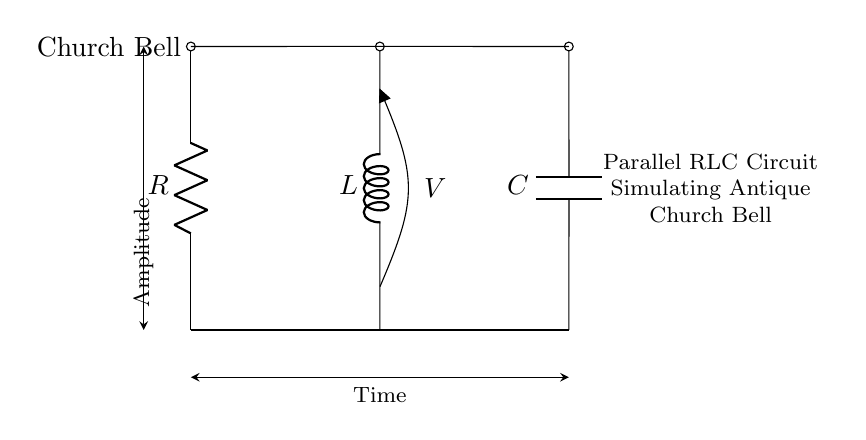What is the type of circuit represented here? This is a parallel RLC circuit, indicated by the arrangement of the resistor, inductor, and capacitor connected in parallel to a common voltage source.
Answer: parallel RLC circuit What are the components of this circuit? The circuit contains a resistor (R), an inductor (L), and a capacitor (C), all properly labeled in the diagram.
Answer: resistor, inductor, capacitor What does the voltage symbol represent in this diagram? The voltage symbol (V) shown in the circuit represents the voltage across the inductor and the capacitor in parallel, which is the same for both components.
Answer: voltage How many components are connected in parallel? There are three components connected in parallel: one resistor, one inductor, and one capacitor.
Answer: three What does the amplitude signify in this diagram? The amplitude denotes the maximum voltage potential in the circuit, depicted vertically along the y-axis, related to the bell's sound characteristics.
Answer: Amplitude What is the effect of increasing the capacitance on the circuit? Increasing the capacitance would generally lower the resonant frequency of the circuit, affecting the sound frequency produced by the bell, leading to a deeper tone.
Answer: lower resonant frequency What is the purpose of the inductor in this circuit? The inductor stores energy in a magnetic field when current flows through it, which contributes to the resonance of the circuit and influences the characteristics of the bell sound.
Answer: store energy 